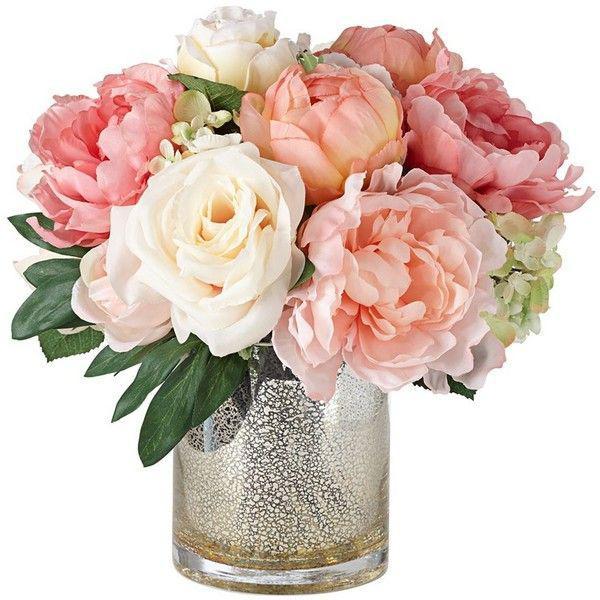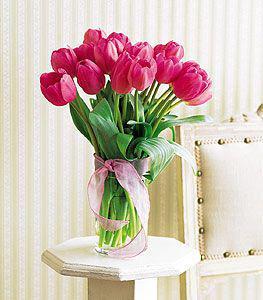The first image is the image on the left, the second image is the image on the right. For the images displayed, is the sentence "A bunch of green stems are visible through the glass in the vase on the right." factually correct? Answer yes or no. Yes. 